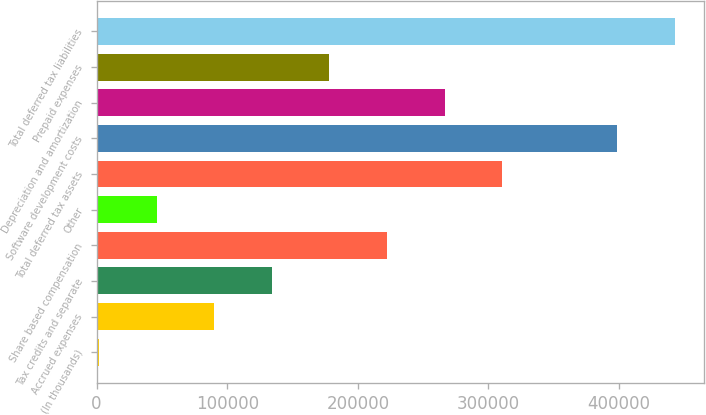Convert chart. <chart><loc_0><loc_0><loc_500><loc_500><bar_chart><fcel>(In thousands)<fcel>Accrued expenses<fcel>Tax credits and separate<fcel>Share based compensation<fcel>Other<fcel>Total deferred tax assets<fcel>Software development costs<fcel>Depreciation and amortization<fcel>Prepaid expenses<fcel>Total deferred tax liabilities<nl><fcel>2016<fcel>90136.2<fcel>134196<fcel>222316<fcel>46076.1<fcel>310437<fcel>398557<fcel>266377<fcel>178256<fcel>442617<nl></chart> 